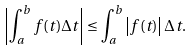<formula> <loc_0><loc_0><loc_500><loc_500>\left | \int \nolimits _ { a } ^ { b } f ( t ) \Delta t \right | \leq \int \nolimits _ { a } ^ { b } \left | f ( t ) \right | \Delta t .</formula> 